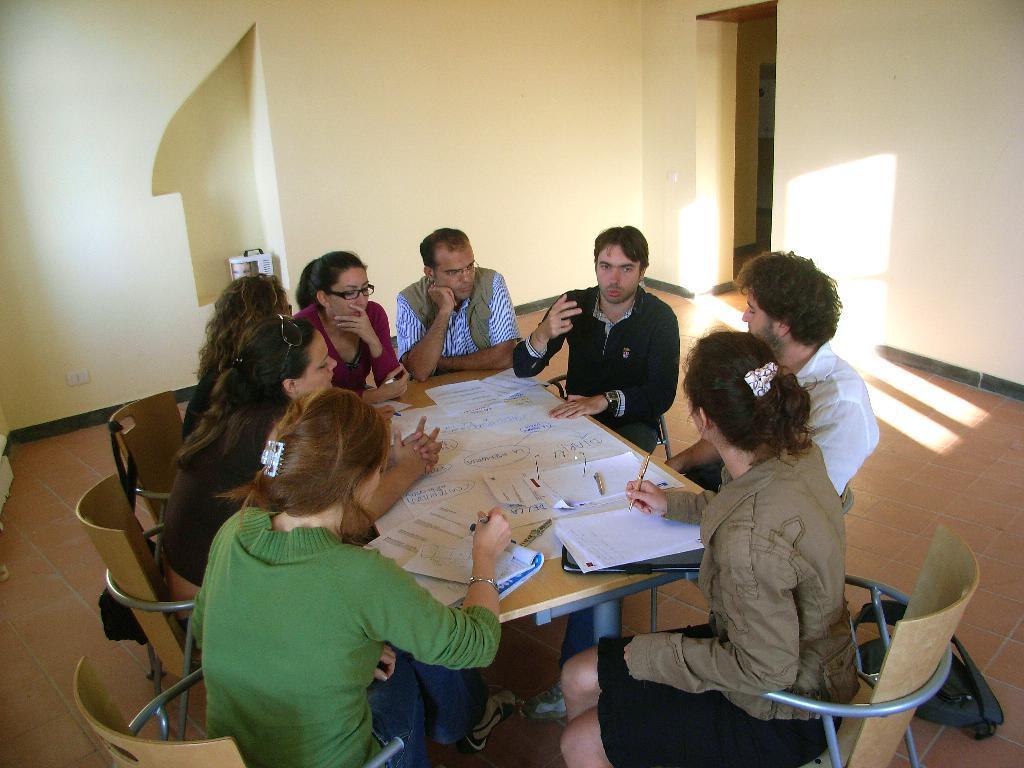Describe this image in one or two sentences. There is a group of people. They are sitting on a chairs. Some persons are wearing a spectacles. There is a table. There is a paper,pen on a table. We can see in the background wall. 